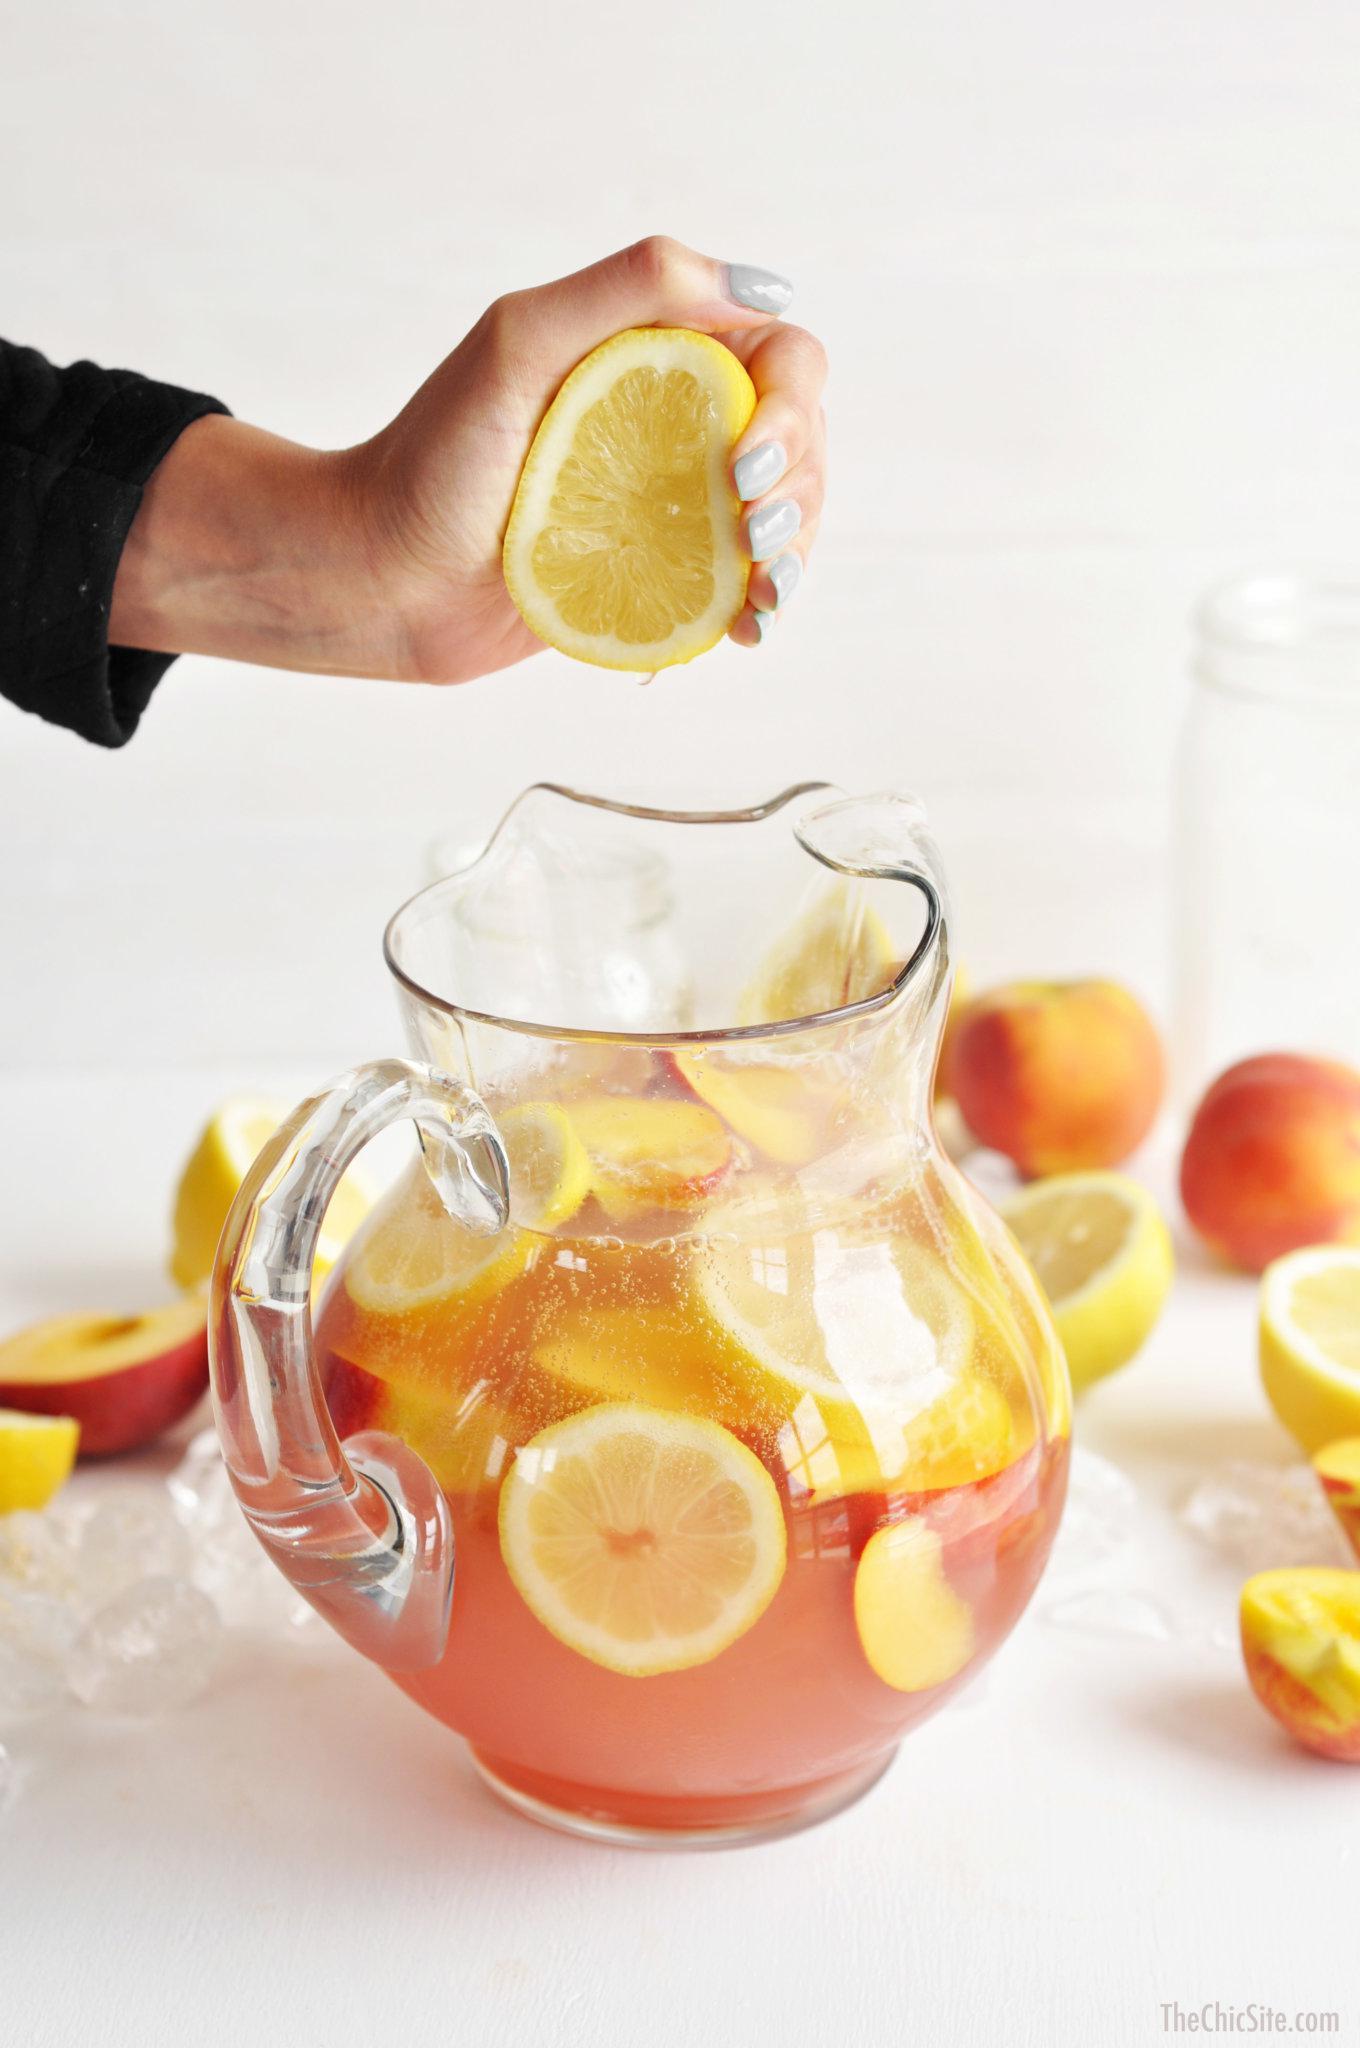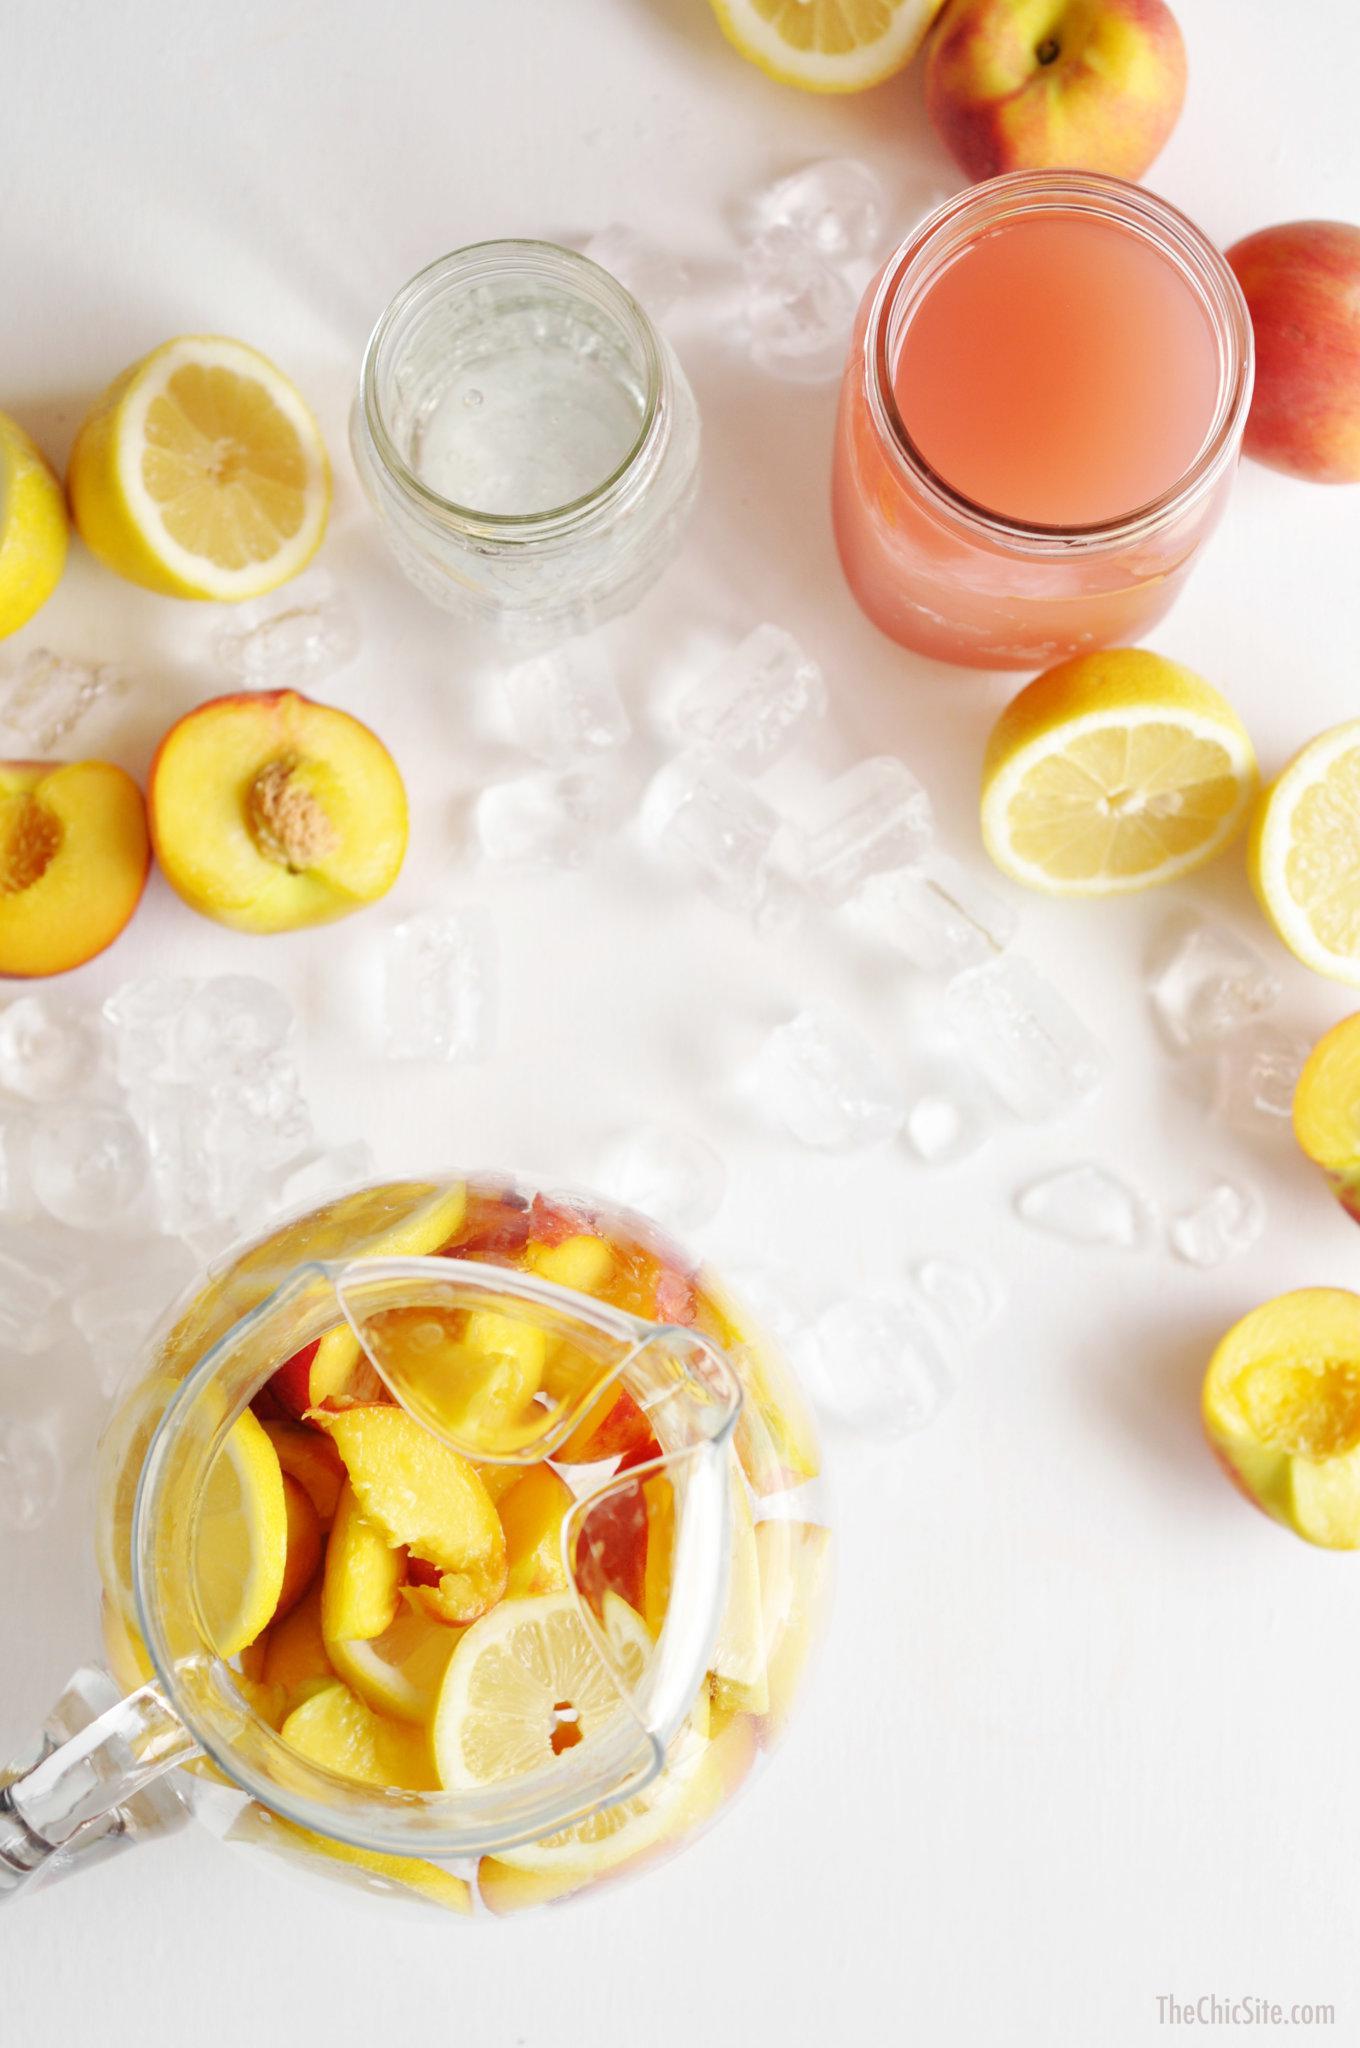The first image is the image on the left, the second image is the image on the right. For the images displayed, is the sentence "A slice of citrus garnishes the drink in at least one of the images." factually correct? Answer yes or no. No. 